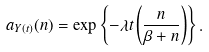<formula> <loc_0><loc_0><loc_500><loc_500>a _ { Y ( t ) } ( n ) = \exp \left \{ - \lambda t \left ( \frac { n } { \beta + n } \right ) \right \} .</formula> 